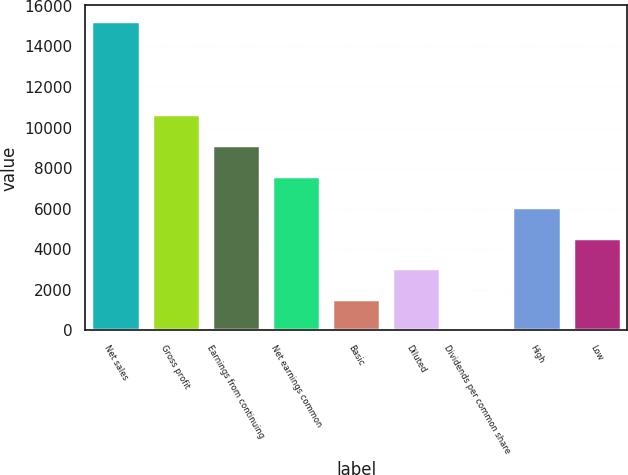<chart> <loc_0><loc_0><loc_500><loc_500><bar_chart><fcel>Net sales<fcel>Gross profit<fcel>Earnings from continuing<fcel>Net earnings common<fcel>Basic<fcel>Diluted<fcel>Dividends per common share<fcel>High<fcel>Low<nl><fcel>15264<fcel>10685.4<fcel>9159.18<fcel>7632.97<fcel>1528.13<fcel>3054.34<fcel>1.92<fcel>6106.76<fcel>4580.55<nl></chart> 